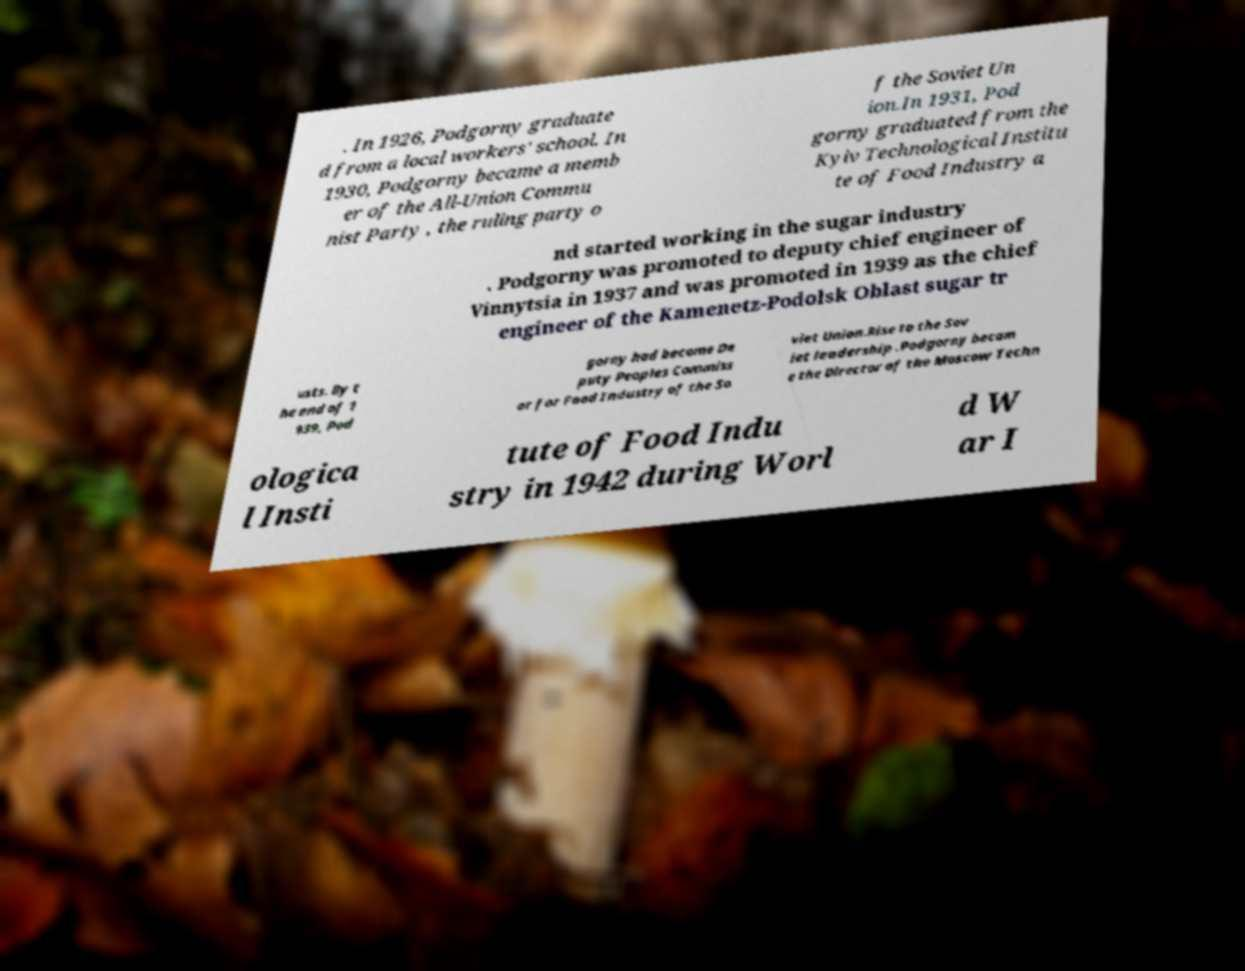Could you extract and type out the text from this image? . In 1926, Podgorny graduate d from a local workers' school. In 1930, Podgorny became a memb er of the All-Union Commu nist Party , the ruling party o f the Soviet Un ion.In 1931, Pod gorny graduated from the Kyiv Technological Institu te of Food Industry a nd started working in the sugar industry . Podgorny was promoted to deputy chief engineer of Vinnytsia in 1937 and was promoted in 1939 as the chief engineer of the Kamenetz-Podolsk Oblast sugar tr usts. By t he end of 1 939, Pod gorny had become De puty Peoples Commiss ar for Food Industry of the So viet Union.Rise to the Sov iet leadership .Podgorny becam e the Director of the Moscow Techn ologica l Insti tute of Food Indu stry in 1942 during Worl d W ar I 